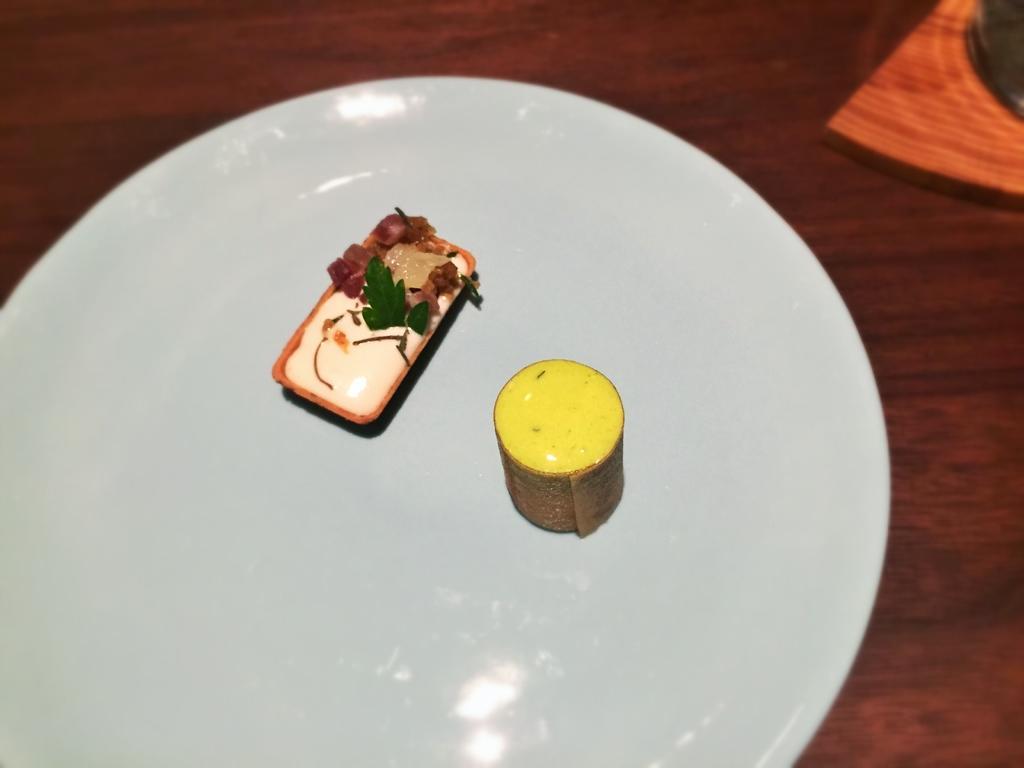Describe this image in one or two sentences. In this image there are food items placed on a plate which is on the table. 